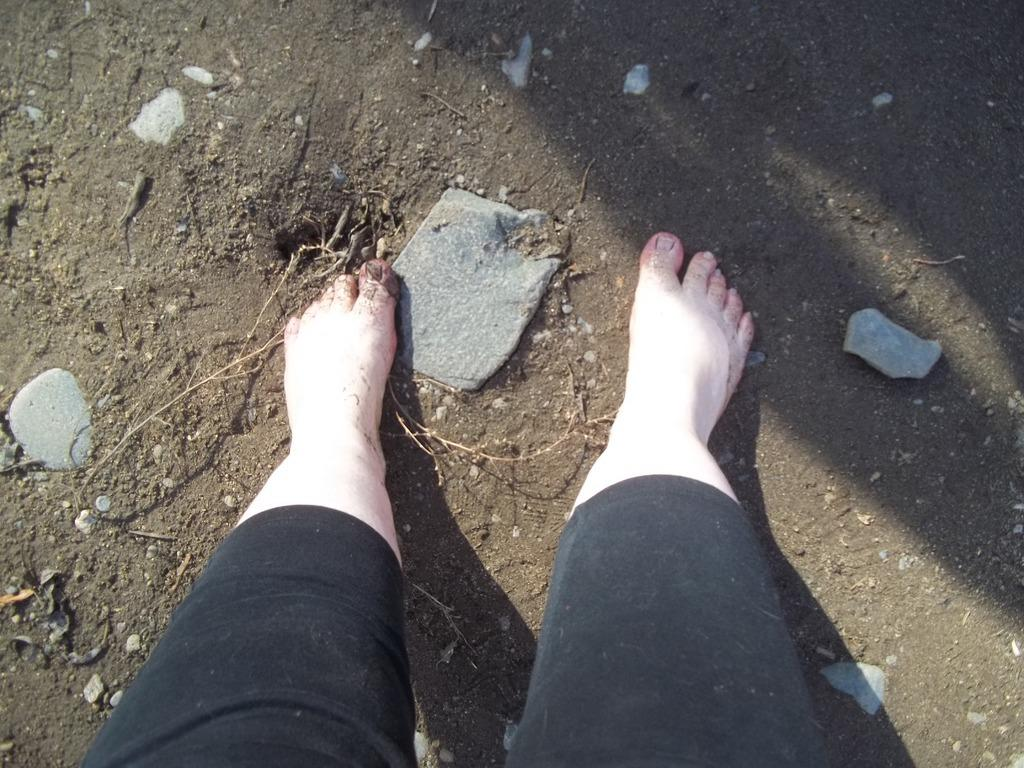What part of a person's body is visible in the image? There is a person's leg in the image. What type of surface is the leg on? The leg is on a mud surface. What else can be seen on the mud surface in the image? There are stones on the mud surface in the image. How many babies are crawling on the person's leg in the image? There are no babies present in the image; it only shows a person's leg on a mud surface with stones. What type of apparel is the person wearing on their leg in the image? The provided facts do not mention any apparel on the person's leg, so we cannot determine what type of apparel they might be wearing. 